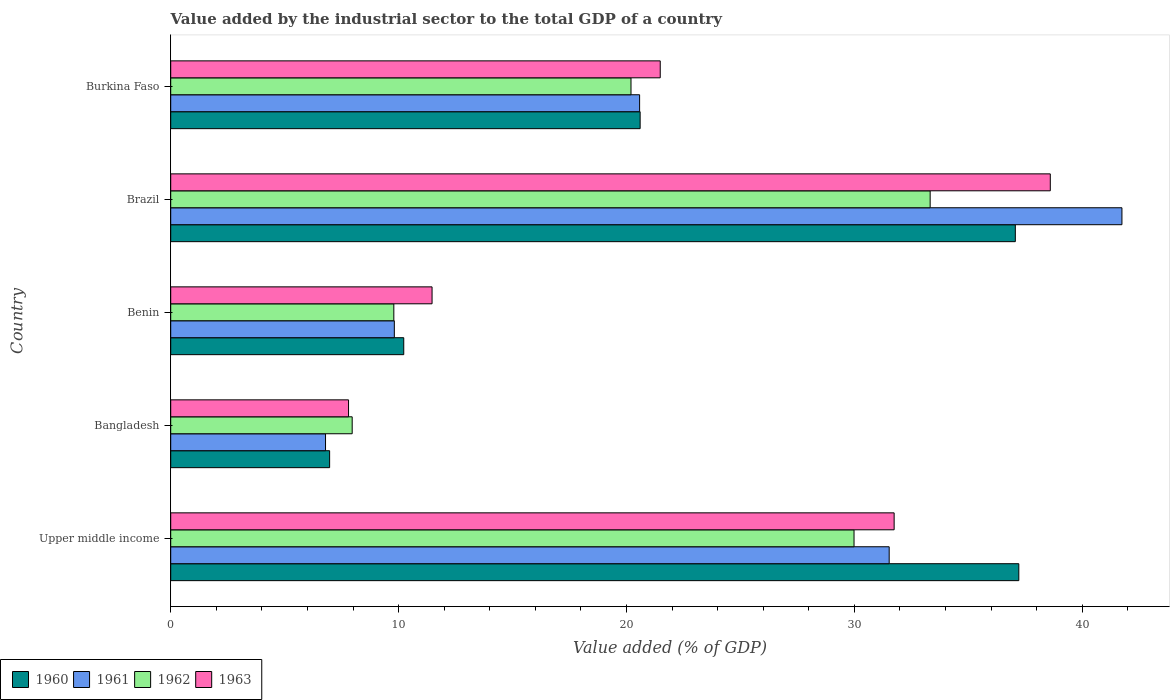How many different coloured bars are there?
Keep it short and to the point. 4. How many groups of bars are there?
Your response must be concise. 5. Are the number of bars on each tick of the Y-axis equal?
Keep it short and to the point. Yes. How many bars are there on the 4th tick from the bottom?
Provide a short and direct response. 4. What is the value added by the industrial sector to the total GDP in 1962 in Benin?
Your answer should be very brief. 9.79. Across all countries, what is the maximum value added by the industrial sector to the total GDP in 1961?
Make the answer very short. 41.75. Across all countries, what is the minimum value added by the industrial sector to the total GDP in 1962?
Keep it short and to the point. 7.96. What is the total value added by the industrial sector to the total GDP in 1960 in the graph?
Give a very brief answer. 112.09. What is the difference between the value added by the industrial sector to the total GDP in 1960 in Brazil and that in Upper middle income?
Keep it short and to the point. -0.15. What is the difference between the value added by the industrial sector to the total GDP in 1961 in Bangladesh and the value added by the industrial sector to the total GDP in 1963 in Benin?
Give a very brief answer. -4.68. What is the average value added by the industrial sector to the total GDP in 1961 per country?
Offer a terse response. 22.09. What is the difference between the value added by the industrial sector to the total GDP in 1962 and value added by the industrial sector to the total GDP in 1961 in Bangladesh?
Your answer should be compact. 1.17. What is the ratio of the value added by the industrial sector to the total GDP in 1961 in Brazil to that in Burkina Faso?
Your answer should be very brief. 2.03. What is the difference between the highest and the second highest value added by the industrial sector to the total GDP in 1963?
Offer a terse response. 6.85. What is the difference between the highest and the lowest value added by the industrial sector to the total GDP in 1960?
Offer a very short reply. 30.25. In how many countries, is the value added by the industrial sector to the total GDP in 1963 greater than the average value added by the industrial sector to the total GDP in 1963 taken over all countries?
Ensure brevity in your answer.  2. Is it the case that in every country, the sum of the value added by the industrial sector to the total GDP in 1960 and value added by the industrial sector to the total GDP in 1962 is greater than the sum of value added by the industrial sector to the total GDP in 1961 and value added by the industrial sector to the total GDP in 1963?
Provide a short and direct response. No. How many bars are there?
Keep it short and to the point. 20. Are all the bars in the graph horizontal?
Offer a very short reply. Yes. How many countries are there in the graph?
Your answer should be compact. 5. What is the difference between two consecutive major ticks on the X-axis?
Offer a very short reply. 10. Does the graph contain any zero values?
Give a very brief answer. No. Where does the legend appear in the graph?
Ensure brevity in your answer.  Bottom left. What is the title of the graph?
Ensure brevity in your answer.  Value added by the industrial sector to the total GDP of a country. Does "2002" appear as one of the legend labels in the graph?
Make the answer very short. No. What is the label or title of the X-axis?
Ensure brevity in your answer.  Value added (% of GDP). What is the label or title of the Y-axis?
Provide a succinct answer. Country. What is the Value added (% of GDP) of 1960 in Upper middle income?
Make the answer very short. 37.22. What is the Value added (% of GDP) in 1961 in Upper middle income?
Keep it short and to the point. 31.53. What is the Value added (% of GDP) of 1962 in Upper middle income?
Give a very brief answer. 29.99. What is the Value added (% of GDP) in 1963 in Upper middle income?
Make the answer very short. 31.75. What is the Value added (% of GDP) in 1960 in Bangladesh?
Ensure brevity in your answer.  6.97. What is the Value added (% of GDP) in 1961 in Bangladesh?
Offer a very short reply. 6.79. What is the Value added (% of GDP) in 1962 in Bangladesh?
Offer a very short reply. 7.96. What is the Value added (% of GDP) in 1963 in Bangladesh?
Keep it short and to the point. 7.8. What is the Value added (% of GDP) in 1960 in Benin?
Give a very brief answer. 10.23. What is the Value added (% of GDP) of 1961 in Benin?
Give a very brief answer. 9.81. What is the Value added (% of GDP) in 1962 in Benin?
Your answer should be very brief. 9.79. What is the Value added (% of GDP) in 1963 in Benin?
Keep it short and to the point. 11.47. What is the Value added (% of GDP) in 1960 in Brazil?
Provide a succinct answer. 37.07. What is the Value added (% of GDP) of 1961 in Brazil?
Keep it short and to the point. 41.75. What is the Value added (% of GDP) in 1962 in Brazil?
Provide a succinct answer. 33.33. What is the Value added (% of GDP) in 1963 in Brazil?
Ensure brevity in your answer.  38.6. What is the Value added (% of GDP) in 1960 in Burkina Faso?
Your answer should be very brief. 20.6. What is the Value added (% of GDP) of 1961 in Burkina Faso?
Your response must be concise. 20.58. What is the Value added (% of GDP) in 1962 in Burkina Faso?
Your answer should be compact. 20.2. What is the Value added (% of GDP) of 1963 in Burkina Faso?
Your answer should be compact. 21.48. Across all countries, what is the maximum Value added (% of GDP) in 1960?
Provide a succinct answer. 37.22. Across all countries, what is the maximum Value added (% of GDP) of 1961?
Your response must be concise. 41.75. Across all countries, what is the maximum Value added (% of GDP) in 1962?
Your response must be concise. 33.33. Across all countries, what is the maximum Value added (% of GDP) in 1963?
Your answer should be very brief. 38.6. Across all countries, what is the minimum Value added (% of GDP) of 1960?
Offer a very short reply. 6.97. Across all countries, what is the minimum Value added (% of GDP) of 1961?
Ensure brevity in your answer.  6.79. Across all countries, what is the minimum Value added (% of GDP) in 1962?
Make the answer very short. 7.96. Across all countries, what is the minimum Value added (% of GDP) of 1963?
Keep it short and to the point. 7.8. What is the total Value added (% of GDP) in 1960 in the graph?
Offer a very short reply. 112.09. What is the total Value added (% of GDP) of 1961 in the graph?
Give a very brief answer. 110.46. What is the total Value added (% of GDP) of 1962 in the graph?
Offer a terse response. 101.27. What is the total Value added (% of GDP) of 1963 in the graph?
Your answer should be compact. 111.11. What is the difference between the Value added (% of GDP) in 1960 in Upper middle income and that in Bangladesh?
Your response must be concise. 30.25. What is the difference between the Value added (% of GDP) in 1961 in Upper middle income and that in Bangladesh?
Ensure brevity in your answer.  24.74. What is the difference between the Value added (% of GDP) of 1962 in Upper middle income and that in Bangladesh?
Your answer should be compact. 22.02. What is the difference between the Value added (% of GDP) of 1963 in Upper middle income and that in Bangladesh?
Offer a very short reply. 23.94. What is the difference between the Value added (% of GDP) in 1960 in Upper middle income and that in Benin?
Your answer should be very brief. 26.99. What is the difference between the Value added (% of GDP) in 1961 in Upper middle income and that in Benin?
Your response must be concise. 21.72. What is the difference between the Value added (% of GDP) of 1962 in Upper middle income and that in Benin?
Offer a very short reply. 20.2. What is the difference between the Value added (% of GDP) of 1963 in Upper middle income and that in Benin?
Offer a very short reply. 20.28. What is the difference between the Value added (% of GDP) in 1960 in Upper middle income and that in Brazil?
Provide a short and direct response. 0.15. What is the difference between the Value added (% of GDP) of 1961 in Upper middle income and that in Brazil?
Offer a terse response. -10.21. What is the difference between the Value added (% of GDP) of 1962 in Upper middle income and that in Brazil?
Offer a terse response. -3.34. What is the difference between the Value added (% of GDP) in 1963 in Upper middle income and that in Brazil?
Make the answer very short. -6.85. What is the difference between the Value added (% of GDP) in 1960 in Upper middle income and that in Burkina Faso?
Give a very brief answer. 16.62. What is the difference between the Value added (% of GDP) in 1961 in Upper middle income and that in Burkina Faso?
Provide a short and direct response. 10.95. What is the difference between the Value added (% of GDP) in 1962 in Upper middle income and that in Burkina Faso?
Your answer should be compact. 9.79. What is the difference between the Value added (% of GDP) in 1963 in Upper middle income and that in Burkina Faso?
Make the answer very short. 10.27. What is the difference between the Value added (% of GDP) of 1960 in Bangladesh and that in Benin?
Your answer should be very brief. -3.25. What is the difference between the Value added (% of GDP) in 1961 in Bangladesh and that in Benin?
Your response must be concise. -3.02. What is the difference between the Value added (% of GDP) in 1962 in Bangladesh and that in Benin?
Provide a succinct answer. -1.83. What is the difference between the Value added (% of GDP) of 1963 in Bangladesh and that in Benin?
Offer a terse response. -3.66. What is the difference between the Value added (% of GDP) of 1960 in Bangladesh and that in Brazil?
Offer a very short reply. -30.09. What is the difference between the Value added (% of GDP) of 1961 in Bangladesh and that in Brazil?
Make the answer very short. -34.95. What is the difference between the Value added (% of GDP) in 1962 in Bangladesh and that in Brazil?
Keep it short and to the point. -25.37. What is the difference between the Value added (% of GDP) of 1963 in Bangladesh and that in Brazil?
Your response must be concise. -30.8. What is the difference between the Value added (% of GDP) in 1960 in Bangladesh and that in Burkina Faso?
Offer a terse response. -13.63. What is the difference between the Value added (% of GDP) in 1961 in Bangladesh and that in Burkina Faso?
Provide a succinct answer. -13.78. What is the difference between the Value added (% of GDP) in 1962 in Bangladesh and that in Burkina Faso?
Offer a very short reply. -12.24. What is the difference between the Value added (% of GDP) of 1963 in Bangladesh and that in Burkina Faso?
Make the answer very short. -13.68. What is the difference between the Value added (% of GDP) of 1960 in Benin and that in Brazil?
Give a very brief answer. -26.84. What is the difference between the Value added (% of GDP) in 1961 in Benin and that in Brazil?
Provide a short and direct response. -31.93. What is the difference between the Value added (% of GDP) in 1962 in Benin and that in Brazil?
Ensure brevity in your answer.  -23.54. What is the difference between the Value added (% of GDP) of 1963 in Benin and that in Brazil?
Your answer should be compact. -27.13. What is the difference between the Value added (% of GDP) of 1960 in Benin and that in Burkina Faso?
Provide a succinct answer. -10.37. What is the difference between the Value added (% of GDP) in 1961 in Benin and that in Burkina Faso?
Your answer should be very brief. -10.76. What is the difference between the Value added (% of GDP) in 1962 in Benin and that in Burkina Faso?
Your answer should be very brief. -10.41. What is the difference between the Value added (% of GDP) in 1963 in Benin and that in Burkina Faso?
Your answer should be very brief. -10.01. What is the difference between the Value added (% of GDP) of 1960 in Brazil and that in Burkina Faso?
Your answer should be compact. 16.47. What is the difference between the Value added (% of GDP) in 1961 in Brazil and that in Burkina Faso?
Your answer should be compact. 21.17. What is the difference between the Value added (% of GDP) in 1962 in Brazil and that in Burkina Faso?
Your answer should be compact. 13.13. What is the difference between the Value added (% of GDP) in 1963 in Brazil and that in Burkina Faso?
Give a very brief answer. 17.12. What is the difference between the Value added (% of GDP) in 1960 in Upper middle income and the Value added (% of GDP) in 1961 in Bangladesh?
Offer a very short reply. 30.43. What is the difference between the Value added (% of GDP) of 1960 in Upper middle income and the Value added (% of GDP) of 1962 in Bangladesh?
Keep it short and to the point. 29.26. What is the difference between the Value added (% of GDP) in 1960 in Upper middle income and the Value added (% of GDP) in 1963 in Bangladesh?
Your answer should be compact. 29.42. What is the difference between the Value added (% of GDP) in 1961 in Upper middle income and the Value added (% of GDP) in 1962 in Bangladesh?
Offer a very short reply. 23.57. What is the difference between the Value added (% of GDP) of 1961 in Upper middle income and the Value added (% of GDP) of 1963 in Bangladesh?
Ensure brevity in your answer.  23.73. What is the difference between the Value added (% of GDP) in 1962 in Upper middle income and the Value added (% of GDP) in 1963 in Bangladesh?
Make the answer very short. 22.18. What is the difference between the Value added (% of GDP) in 1960 in Upper middle income and the Value added (% of GDP) in 1961 in Benin?
Your response must be concise. 27.41. What is the difference between the Value added (% of GDP) of 1960 in Upper middle income and the Value added (% of GDP) of 1962 in Benin?
Offer a terse response. 27.43. What is the difference between the Value added (% of GDP) of 1960 in Upper middle income and the Value added (% of GDP) of 1963 in Benin?
Make the answer very short. 25.75. What is the difference between the Value added (% of GDP) of 1961 in Upper middle income and the Value added (% of GDP) of 1962 in Benin?
Provide a short and direct response. 21.74. What is the difference between the Value added (% of GDP) of 1961 in Upper middle income and the Value added (% of GDP) of 1963 in Benin?
Your answer should be compact. 20.06. What is the difference between the Value added (% of GDP) of 1962 in Upper middle income and the Value added (% of GDP) of 1963 in Benin?
Provide a short and direct response. 18.52. What is the difference between the Value added (% of GDP) of 1960 in Upper middle income and the Value added (% of GDP) of 1961 in Brazil?
Provide a short and direct response. -4.53. What is the difference between the Value added (% of GDP) in 1960 in Upper middle income and the Value added (% of GDP) in 1962 in Brazil?
Provide a succinct answer. 3.89. What is the difference between the Value added (% of GDP) in 1960 in Upper middle income and the Value added (% of GDP) in 1963 in Brazil?
Offer a terse response. -1.38. What is the difference between the Value added (% of GDP) of 1961 in Upper middle income and the Value added (% of GDP) of 1962 in Brazil?
Keep it short and to the point. -1.8. What is the difference between the Value added (% of GDP) in 1961 in Upper middle income and the Value added (% of GDP) in 1963 in Brazil?
Your answer should be compact. -7.07. What is the difference between the Value added (% of GDP) in 1962 in Upper middle income and the Value added (% of GDP) in 1963 in Brazil?
Ensure brevity in your answer.  -8.61. What is the difference between the Value added (% of GDP) of 1960 in Upper middle income and the Value added (% of GDP) of 1961 in Burkina Faso?
Provide a succinct answer. 16.64. What is the difference between the Value added (% of GDP) in 1960 in Upper middle income and the Value added (% of GDP) in 1962 in Burkina Faso?
Your answer should be very brief. 17.02. What is the difference between the Value added (% of GDP) of 1960 in Upper middle income and the Value added (% of GDP) of 1963 in Burkina Faso?
Provide a succinct answer. 15.74. What is the difference between the Value added (% of GDP) of 1961 in Upper middle income and the Value added (% of GDP) of 1962 in Burkina Faso?
Ensure brevity in your answer.  11.33. What is the difference between the Value added (% of GDP) in 1961 in Upper middle income and the Value added (% of GDP) in 1963 in Burkina Faso?
Give a very brief answer. 10.05. What is the difference between the Value added (% of GDP) in 1962 in Upper middle income and the Value added (% of GDP) in 1963 in Burkina Faso?
Ensure brevity in your answer.  8.5. What is the difference between the Value added (% of GDP) in 1960 in Bangladesh and the Value added (% of GDP) in 1961 in Benin?
Provide a short and direct response. -2.84. What is the difference between the Value added (% of GDP) in 1960 in Bangladesh and the Value added (% of GDP) in 1962 in Benin?
Provide a succinct answer. -2.82. What is the difference between the Value added (% of GDP) in 1960 in Bangladesh and the Value added (% of GDP) in 1963 in Benin?
Offer a terse response. -4.5. What is the difference between the Value added (% of GDP) in 1961 in Bangladesh and the Value added (% of GDP) in 1962 in Benin?
Offer a terse response. -3. What is the difference between the Value added (% of GDP) of 1961 in Bangladesh and the Value added (% of GDP) of 1963 in Benin?
Offer a terse response. -4.68. What is the difference between the Value added (% of GDP) in 1962 in Bangladesh and the Value added (% of GDP) in 1963 in Benin?
Offer a terse response. -3.51. What is the difference between the Value added (% of GDP) in 1960 in Bangladesh and the Value added (% of GDP) in 1961 in Brazil?
Ensure brevity in your answer.  -34.77. What is the difference between the Value added (% of GDP) of 1960 in Bangladesh and the Value added (% of GDP) of 1962 in Brazil?
Your answer should be compact. -26.36. What is the difference between the Value added (% of GDP) of 1960 in Bangladesh and the Value added (% of GDP) of 1963 in Brazil?
Provide a short and direct response. -31.63. What is the difference between the Value added (% of GDP) in 1961 in Bangladesh and the Value added (% of GDP) in 1962 in Brazil?
Give a very brief answer. -26.53. What is the difference between the Value added (% of GDP) of 1961 in Bangladesh and the Value added (% of GDP) of 1963 in Brazil?
Offer a terse response. -31.81. What is the difference between the Value added (% of GDP) in 1962 in Bangladesh and the Value added (% of GDP) in 1963 in Brazil?
Offer a very short reply. -30.64. What is the difference between the Value added (% of GDP) of 1960 in Bangladesh and the Value added (% of GDP) of 1961 in Burkina Faso?
Ensure brevity in your answer.  -13.6. What is the difference between the Value added (% of GDP) in 1960 in Bangladesh and the Value added (% of GDP) in 1962 in Burkina Faso?
Offer a very short reply. -13.23. What is the difference between the Value added (% of GDP) in 1960 in Bangladesh and the Value added (% of GDP) in 1963 in Burkina Faso?
Provide a succinct answer. -14.51. What is the difference between the Value added (% of GDP) in 1961 in Bangladesh and the Value added (% of GDP) in 1962 in Burkina Faso?
Provide a succinct answer. -13.41. What is the difference between the Value added (% of GDP) of 1961 in Bangladesh and the Value added (% of GDP) of 1963 in Burkina Faso?
Give a very brief answer. -14.69. What is the difference between the Value added (% of GDP) in 1962 in Bangladesh and the Value added (% of GDP) in 1963 in Burkina Faso?
Offer a very short reply. -13.52. What is the difference between the Value added (% of GDP) of 1960 in Benin and the Value added (% of GDP) of 1961 in Brazil?
Provide a short and direct response. -31.52. What is the difference between the Value added (% of GDP) in 1960 in Benin and the Value added (% of GDP) in 1962 in Brazil?
Provide a succinct answer. -23.1. What is the difference between the Value added (% of GDP) of 1960 in Benin and the Value added (% of GDP) of 1963 in Brazil?
Offer a terse response. -28.37. What is the difference between the Value added (% of GDP) of 1961 in Benin and the Value added (% of GDP) of 1962 in Brazil?
Offer a terse response. -23.52. What is the difference between the Value added (% of GDP) of 1961 in Benin and the Value added (% of GDP) of 1963 in Brazil?
Provide a succinct answer. -28.79. What is the difference between the Value added (% of GDP) in 1962 in Benin and the Value added (% of GDP) in 1963 in Brazil?
Your answer should be very brief. -28.81. What is the difference between the Value added (% of GDP) in 1960 in Benin and the Value added (% of GDP) in 1961 in Burkina Faso?
Provide a succinct answer. -10.35. What is the difference between the Value added (% of GDP) in 1960 in Benin and the Value added (% of GDP) in 1962 in Burkina Faso?
Offer a very short reply. -9.97. What is the difference between the Value added (% of GDP) in 1960 in Benin and the Value added (% of GDP) in 1963 in Burkina Faso?
Make the answer very short. -11.26. What is the difference between the Value added (% of GDP) of 1961 in Benin and the Value added (% of GDP) of 1962 in Burkina Faso?
Keep it short and to the point. -10.39. What is the difference between the Value added (% of GDP) in 1961 in Benin and the Value added (% of GDP) in 1963 in Burkina Faso?
Keep it short and to the point. -11.67. What is the difference between the Value added (% of GDP) in 1962 in Benin and the Value added (% of GDP) in 1963 in Burkina Faso?
Provide a succinct answer. -11.69. What is the difference between the Value added (% of GDP) in 1960 in Brazil and the Value added (% of GDP) in 1961 in Burkina Faso?
Your answer should be compact. 16.49. What is the difference between the Value added (% of GDP) in 1960 in Brazil and the Value added (% of GDP) in 1962 in Burkina Faso?
Your answer should be very brief. 16.87. What is the difference between the Value added (% of GDP) of 1960 in Brazil and the Value added (% of GDP) of 1963 in Burkina Faso?
Ensure brevity in your answer.  15.58. What is the difference between the Value added (% of GDP) in 1961 in Brazil and the Value added (% of GDP) in 1962 in Burkina Faso?
Your answer should be compact. 21.54. What is the difference between the Value added (% of GDP) of 1961 in Brazil and the Value added (% of GDP) of 1963 in Burkina Faso?
Your answer should be very brief. 20.26. What is the difference between the Value added (% of GDP) in 1962 in Brazil and the Value added (% of GDP) in 1963 in Burkina Faso?
Provide a succinct answer. 11.85. What is the average Value added (% of GDP) in 1960 per country?
Make the answer very short. 22.42. What is the average Value added (% of GDP) in 1961 per country?
Ensure brevity in your answer.  22.09. What is the average Value added (% of GDP) in 1962 per country?
Offer a terse response. 20.25. What is the average Value added (% of GDP) of 1963 per country?
Give a very brief answer. 22.22. What is the difference between the Value added (% of GDP) of 1960 and Value added (% of GDP) of 1961 in Upper middle income?
Offer a very short reply. 5.69. What is the difference between the Value added (% of GDP) of 1960 and Value added (% of GDP) of 1962 in Upper middle income?
Keep it short and to the point. 7.23. What is the difference between the Value added (% of GDP) of 1960 and Value added (% of GDP) of 1963 in Upper middle income?
Provide a short and direct response. 5.47. What is the difference between the Value added (% of GDP) of 1961 and Value added (% of GDP) of 1962 in Upper middle income?
Ensure brevity in your answer.  1.54. What is the difference between the Value added (% of GDP) of 1961 and Value added (% of GDP) of 1963 in Upper middle income?
Your response must be concise. -0.22. What is the difference between the Value added (% of GDP) in 1962 and Value added (% of GDP) in 1963 in Upper middle income?
Your answer should be compact. -1.76. What is the difference between the Value added (% of GDP) in 1960 and Value added (% of GDP) in 1961 in Bangladesh?
Offer a terse response. 0.18. What is the difference between the Value added (% of GDP) in 1960 and Value added (% of GDP) in 1962 in Bangladesh?
Provide a short and direct response. -0.99. What is the difference between the Value added (% of GDP) in 1960 and Value added (% of GDP) in 1963 in Bangladesh?
Your answer should be very brief. -0.83. What is the difference between the Value added (% of GDP) in 1961 and Value added (% of GDP) in 1962 in Bangladesh?
Provide a succinct answer. -1.17. What is the difference between the Value added (% of GDP) of 1961 and Value added (% of GDP) of 1963 in Bangladesh?
Your answer should be very brief. -1.01. What is the difference between the Value added (% of GDP) of 1962 and Value added (% of GDP) of 1963 in Bangladesh?
Your response must be concise. 0.16. What is the difference between the Value added (% of GDP) in 1960 and Value added (% of GDP) in 1961 in Benin?
Ensure brevity in your answer.  0.41. What is the difference between the Value added (% of GDP) in 1960 and Value added (% of GDP) in 1962 in Benin?
Your response must be concise. 0.44. What is the difference between the Value added (% of GDP) in 1960 and Value added (% of GDP) in 1963 in Benin?
Offer a very short reply. -1.24. What is the difference between the Value added (% of GDP) in 1961 and Value added (% of GDP) in 1962 in Benin?
Ensure brevity in your answer.  0.02. What is the difference between the Value added (% of GDP) in 1961 and Value added (% of GDP) in 1963 in Benin?
Your answer should be very brief. -1.66. What is the difference between the Value added (% of GDP) of 1962 and Value added (% of GDP) of 1963 in Benin?
Offer a very short reply. -1.68. What is the difference between the Value added (% of GDP) of 1960 and Value added (% of GDP) of 1961 in Brazil?
Your answer should be compact. -4.68. What is the difference between the Value added (% of GDP) in 1960 and Value added (% of GDP) in 1962 in Brazil?
Offer a very short reply. 3.74. What is the difference between the Value added (% of GDP) of 1960 and Value added (% of GDP) of 1963 in Brazil?
Your response must be concise. -1.53. What is the difference between the Value added (% of GDP) in 1961 and Value added (% of GDP) in 1962 in Brazil?
Provide a short and direct response. 8.42. What is the difference between the Value added (% of GDP) in 1961 and Value added (% of GDP) in 1963 in Brazil?
Provide a succinct answer. 3.14. What is the difference between the Value added (% of GDP) in 1962 and Value added (% of GDP) in 1963 in Brazil?
Make the answer very short. -5.27. What is the difference between the Value added (% of GDP) in 1960 and Value added (% of GDP) in 1961 in Burkina Faso?
Ensure brevity in your answer.  0.02. What is the difference between the Value added (% of GDP) of 1960 and Value added (% of GDP) of 1962 in Burkina Faso?
Your answer should be compact. 0.4. What is the difference between the Value added (% of GDP) of 1960 and Value added (% of GDP) of 1963 in Burkina Faso?
Your answer should be compact. -0.88. What is the difference between the Value added (% of GDP) of 1961 and Value added (% of GDP) of 1962 in Burkina Faso?
Keep it short and to the point. 0.38. What is the difference between the Value added (% of GDP) of 1961 and Value added (% of GDP) of 1963 in Burkina Faso?
Your answer should be very brief. -0.91. What is the difference between the Value added (% of GDP) of 1962 and Value added (% of GDP) of 1963 in Burkina Faso?
Your answer should be very brief. -1.28. What is the ratio of the Value added (% of GDP) of 1960 in Upper middle income to that in Bangladesh?
Your answer should be very brief. 5.34. What is the ratio of the Value added (% of GDP) in 1961 in Upper middle income to that in Bangladesh?
Provide a succinct answer. 4.64. What is the ratio of the Value added (% of GDP) in 1962 in Upper middle income to that in Bangladesh?
Make the answer very short. 3.77. What is the ratio of the Value added (% of GDP) of 1963 in Upper middle income to that in Bangladesh?
Your response must be concise. 4.07. What is the ratio of the Value added (% of GDP) in 1960 in Upper middle income to that in Benin?
Your answer should be compact. 3.64. What is the ratio of the Value added (% of GDP) of 1961 in Upper middle income to that in Benin?
Offer a very short reply. 3.21. What is the ratio of the Value added (% of GDP) in 1962 in Upper middle income to that in Benin?
Offer a terse response. 3.06. What is the ratio of the Value added (% of GDP) in 1963 in Upper middle income to that in Benin?
Provide a succinct answer. 2.77. What is the ratio of the Value added (% of GDP) in 1960 in Upper middle income to that in Brazil?
Provide a succinct answer. 1. What is the ratio of the Value added (% of GDP) of 1961 in Upper middle income to that in Brazil?
Offer a terse response. 0.76. What is the ratio of the Value added (% of GDP) in 1962 in Upper middle income to that in Brazil?
Ensure brevity in your answer.  0.9. What is the ratio of the Value added (% of GDP) in 1963 in Upper middle income to that in Brazil?
Make the answer very short. 0.82. What is the ratio of the Value added (% of GDP) of 1960 in Upper middle income to that in Burkina Faso?
Your answer should be compact. 1.81. What is the ratio of the Value added (% of GDP) of 1961 in Upper middle income to that in Burkina Faso?
Provide a short and direct response. 1.53. What is the ratio of the Value added (% of GDP) of 1962 in Upper middle income to that in Burkina Faso?
Give a very brief answer. 1.48. What is the ratio of the Value added (% of GDP) in 1963 in Upper middle income to that in Burkina Faso?
Provide a short and direct response. 1.48. What is the ratio of the Value added (% of GDP) in 1960 in Bangladesh to that in Benin?
Your answer should be compact. 0.68. What is the ratio of the Value added (% of GDP) of 1961 in Bangladesh to that in Benin?
Your response must be concise. 0.69. What is the ratio of the Value added (% of GDP) of 1962 in Bangladesh to that in Benin?
Provide a succinct answer. 0.81. What is the ratio of the Value added (% of GDP) of 1963 in Bangladesh to that in Benin?
Give a very brief answer. 0.68. What is the ratio of the Value added (% of GDP) in 1960 in Bangladesh to that in Brazil?
Give a very brief answer. 0.19. What is the ratio of the Value added (% of GDP) of 1961 in Bangladesh to that in Brazil?
Your answer should be very brief. 0.16. What is the ratio of the Value added (% of GDP) in 1962 in Bangladesh to that in Brazil?
Your answer should be very brief. 0.24. What is the ratio of the Value added (% of GDP) in 1963 in Bangladesh to that in Brazil?
Ensure brevity in your answer.  0.2. What is the ratio of the Value added (% of GDP) in 1960 in Bangladesh to that in Burkina Faso?
Make the answer very short. 0.34. What is the ratio of the Value added (% of GDP) of 1961 in Bangladesh to that in Burkina Faso?
Your answer should be compact. 0.33. What is the ratio of the Value added (% of GDP) of 1962 in Bangladesh to that in Burkina Faso?
Offer a terse response. 0.39. What is the ratio of the Value added (% of GDP) of 1963 in Bangladesh to that in Burkina Faso?
Offer a very short reply. 0.36. What is the ratio of the Value added (% of GDP) in 1960 in Benin to that in Brazil?
Your response must be concise. 0.28. What is the ratio of the Value added (% of GDP) of 1961 in Benin to that in Brazil?
Your answer should be very brief. 0.24. What is the ratio of the Value added (% of GDP) in 1962 in Benin to that in Brazil?
Your answer should be compact. 0.29. What is the ratio of the Value added (% of GDP) of 1963 in Benin to that in Brazil?
Provide a short and direct response. 0.3. What is the ratio of the Value added (% of GDP) in 1960 in Benin to that in Burkina Faso?
Give a very brief answer. 0.5. What is the ratio of the Value added (% of GDP) in 1961 in Benin to that in Burkina Faso?
Offer a very short reply. 0.48. What is the ratio of the Value added (% of GDP) in 1962 in Benin to that in Burkina Faso?
Your answer should be compact. 0.48. What is the ratio of the Value added (% of GDP) of 1963 in Benin to that in Burkina Faso?
Provide a succinct answer. 0.53. What is the ratio of the Value added (% of GDP) of 1960 in Brazil to that in Burkina Faso?
Your answer should be very brief. 1.8. What is the ratio of the Value added (% of GDP) in 1961 in Brazil to that in Burkina Faso?
Keep it short and to the point. 2.03. What is the ratio of the Value added (% of GDP) of 1962 in Brazil to that in Burkina Faso?
Your answer should be compact. 1.65. What is the ratio of the Value added (% of GDP) of 1963 in Brazil to that in Burkina Faso?
Offer a terse response. 1.8. What is the difference between the highest and the second highest Value added (% of GDP) of 1960?
Offer a terse response. 0.15. What is the difference between the highest and the second highest Value added (% of GDP) in 1961?
Offer a very short reply. 10.21. What is the difference between the highest and the second highest Value added (% of GDP) in 1962?
Provide a succinct answer. 3.34. What is the difference between the highest and the second highest Value added (% of GDP) in 1963?
Your answer should be very brief. 6.85. What is the difference between the highest and the lowest Value added (% of GDP) of 1960?
Provide a succinct answer. 30.25. What is the difference between the highest and the lowest Value added (% of GDP) of 1961?
Your answer should be compact. 34.95. What is the difference between the highest and the lowest Value added (% of GDP) of 1962?
Offer a terse response. 25.37. What is the difference between the highest and the lowest Value added (% of GDP) of 1963?
Your answer should be compact. 30.8. 